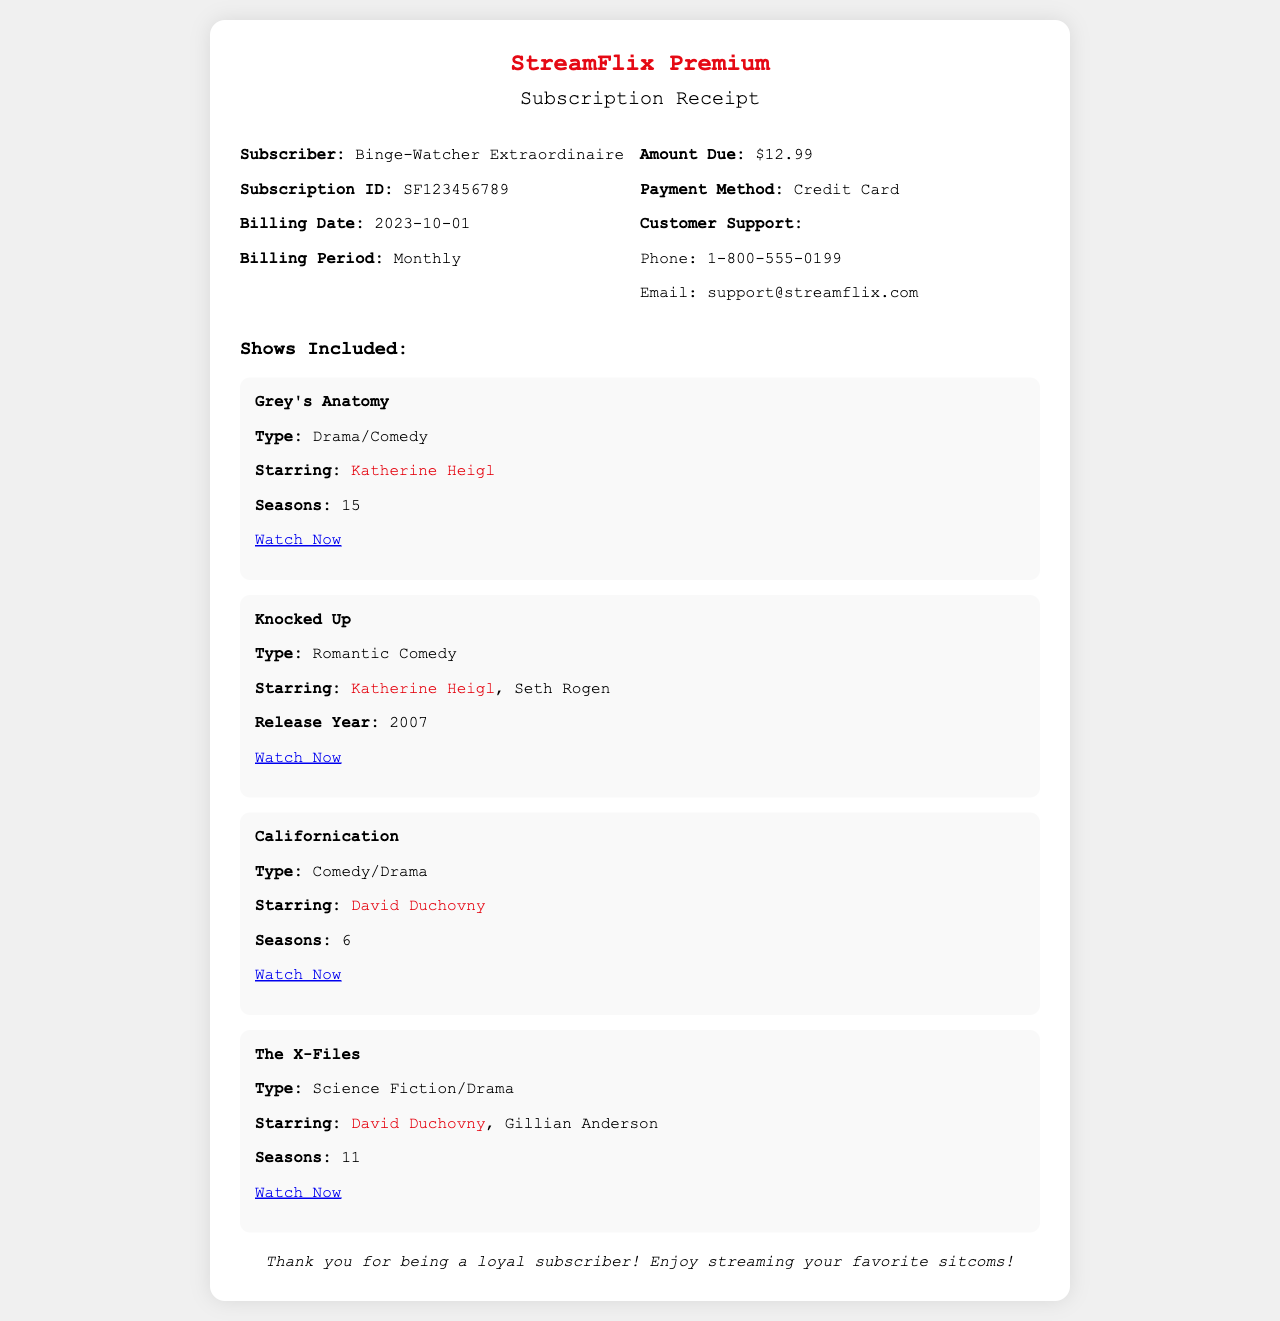What is the name of the subscriber? The subscriber's name is mentioned at the beginning of the document.
Answer: Binge-Watcher Extraordinaire What is the subscription ID? The subscription ID can be found in the details section of the receipt.
Answer: SF123456789 When is the billing date? The billing date is listed in the details portion of the receipt.
Answer: 2023-10-01 How much is the amount due? The amount due is specified in the right details section of the receipt.
Answer: $12.99 Which show features Katherine Heigl? The shows starring Katherine Heigl are mentioned in the shows included section.
Answer: Grey's Anatomy How many seasons does Californication have? The number of seasons for Californication can be found in its details.
Answer: 6 What type of show is Knocked Up? The type of Knocked Up is provided in the show details.
Answer: Romantic Comedy Who co-stars with David Duchovny in The X-Files? The co-star of David Duchovny is revealed in the show details.
Answer: Gillian Anderson What is the payment method listed? The payment method is found in the right details section of the receipt.
Answer: Credit Card 